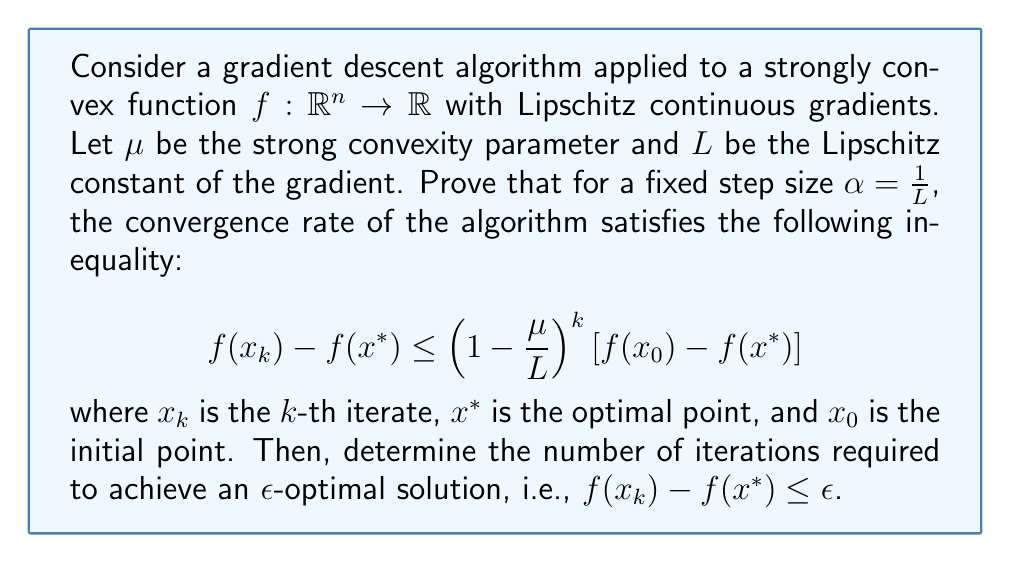Show me your answer to this math problem. To prove this inequality and determine the number of iterations, we'll follow these steps:

1) First, recall the update rule for gradient descent:
   $$x_{k+1} = x_k - \alpha \nabla f(x_k)$$

2) For a strongly convex function with Lipschitz continuous gradients, we have:
   $$\frac{\mu}{2}\|x-y\|^2 \leq f(x) - f(y) - \langle \nabla f(y), x-y \rangle \leq \frac{L}{2}\|x-y\|^2$$

3) Using the right-hand side of this inequality with $x = x^*$ and $y = x_k$:
   $$f(x^*) \geq f(x_k) + \langle \nabla f(x_k), x^* - x_k \rangle + \frac{1}{2L}\|\nabla f(x_k)\|^2$$

4) Rearranging:
   $$f(x_k) - f(x^*) \leq \langle \nabla f(x_k), x_k - x^* \rangle - \frac{1}{2L}\|\nabla f(x_k)\|^2$$

5) Now, consider the progress made in one step:
   \begin{align*}
   \|x_{k+1} - x^*\|^2 &= \|x_k - \frac{1}{L}\nabla f(x_k) - x^*\|^2 \\
   &= \|x_k - x^*\|^2 - \frac{2}{L}\langle \nabla f(x_k), x_k - x^* \rangle + \frac{1}{L^2}\|\nabla f(x_k)\|^2
   \end{align*}

6) Rearranging:
   $$\langle \nabla f(x_k), x_k - x^* \rangle = \frac{L}{2}(\|x_k - x^*\|^2 - \|x_{k+1} - x^*\|^2) + \frac{1}{2L}\|\nabla f(x_k)\|^2$$

7) Substituting this into the inequality from step 4:
   $$f(x_k) - f(x^*) \leq \frac{L}{2}(\|x_k - x^*\|^2 - \|x_{k+1} - x^*\|^2)$$

8) Using the left-hand side of the inequality from step 2:
   $$\frac{\mu}{2}\|x_k - x^*\|^2 \leq f(x_k) - f(x^*)$$

9) Combining the last two inequalities:
   $$\frac{\mu}{2}\|x_{k+1} - x^*\|^2 \leq f(x_{k+1}) - f(x^*) \leq \frac{L}{2}(\|x_k - x^*\|^2 - \|x_{k+1} - x^*\|^2)$$

10) Rearranging:
    $$\|x_{k+1} - x^*\|^2 \leq (1 - \frac{\mu}{L})\|x_k - x^*\|^2$$

11) Applying this recursively:
    $$\|x_k - x^*\|^2 \leq (1 - \frac{\mu}{L})^k \|x_0 - x^*\|^2$$

12) Combining with the inequality from step 8:
    $$f(x_k) - f(x^*) \leq \frac{L}{2}(1 - \frac{\mu}{L})^k \|x_0 - x^*\|^2 \leq (1 - \frac{\mu}{L})^k [f(x_0) - f(x^*)]$$

This proves the desired inequality.

To determine the number of iterations needed for an $\epsilon$-optimal solution:

13) We want: $(1 - \frac{\mu}{L})^k [f(x_0) - f(x^*)] \leq \epsilon$

14) Taking logarithms:
    $$k \log(1 - \frac{\mu}{L}) \leq \log(\frac{\epsilon}{f(x_0) - f(x^*)})$$

15) Using the inequality $\log(1-x) \leq -x$ for $x \in (0,1)$:
    $$-k \frac{\mu}{L} \leq \log(\frac{\epsilon}{f(x_0) - f(x^*)})$$

16) Solving for $k$:
    $$k \geq \frac{L}{\mu} \log(\frac{f(x_0) - f(x^*)}{\epsilon})$$
Answer: The convergence rate inequality is proved as:
$$f(x_k) - f(x^*) \leq \left(1 - \frac{\mu}{L}\right)^k [f(x_0) - f(x^*)]$$

The number of iterations required to achieve an $\epsilon$-optimal solution is:
$$k \geq \frac{L}{\mu} \log(\frac{f(x_0) - f(x^*)}{\epsilon})$$ 